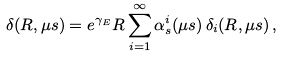<formula> <loc_0><loc_0><loc_500><loc_500>\delta ( R , \mu s ) = e ^ { \gamma _ { E } } R \sum _ { i = 1 } ^ { \infty } \alpha _ { s } ^ { i } ( \mu s ) \, \delta _ { i } ( R , \mu s ) \, ,</formula> 